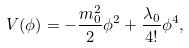Convert formula to latex. <formula><loc_0><loc_0><loc_500><loc_500>V ( \phi ) = - \frac { m _ { 0 } ^ { 2 } } { 2 } \phi ^ { 2 } + \frac { \lambda _ { 0 } } { 4 ! } \phi ^ { 4 } ,</formula> 